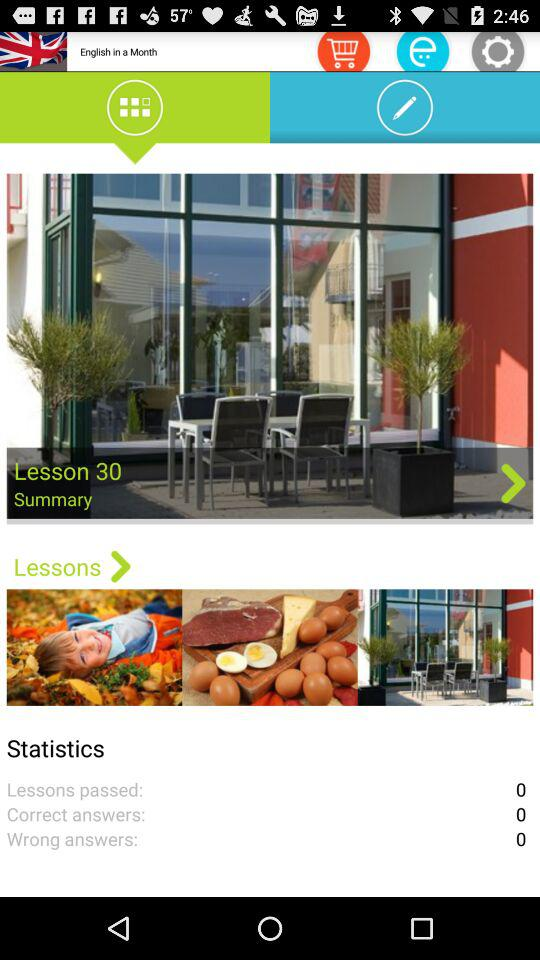How many correct answers are there? There are 0 correct answers. 